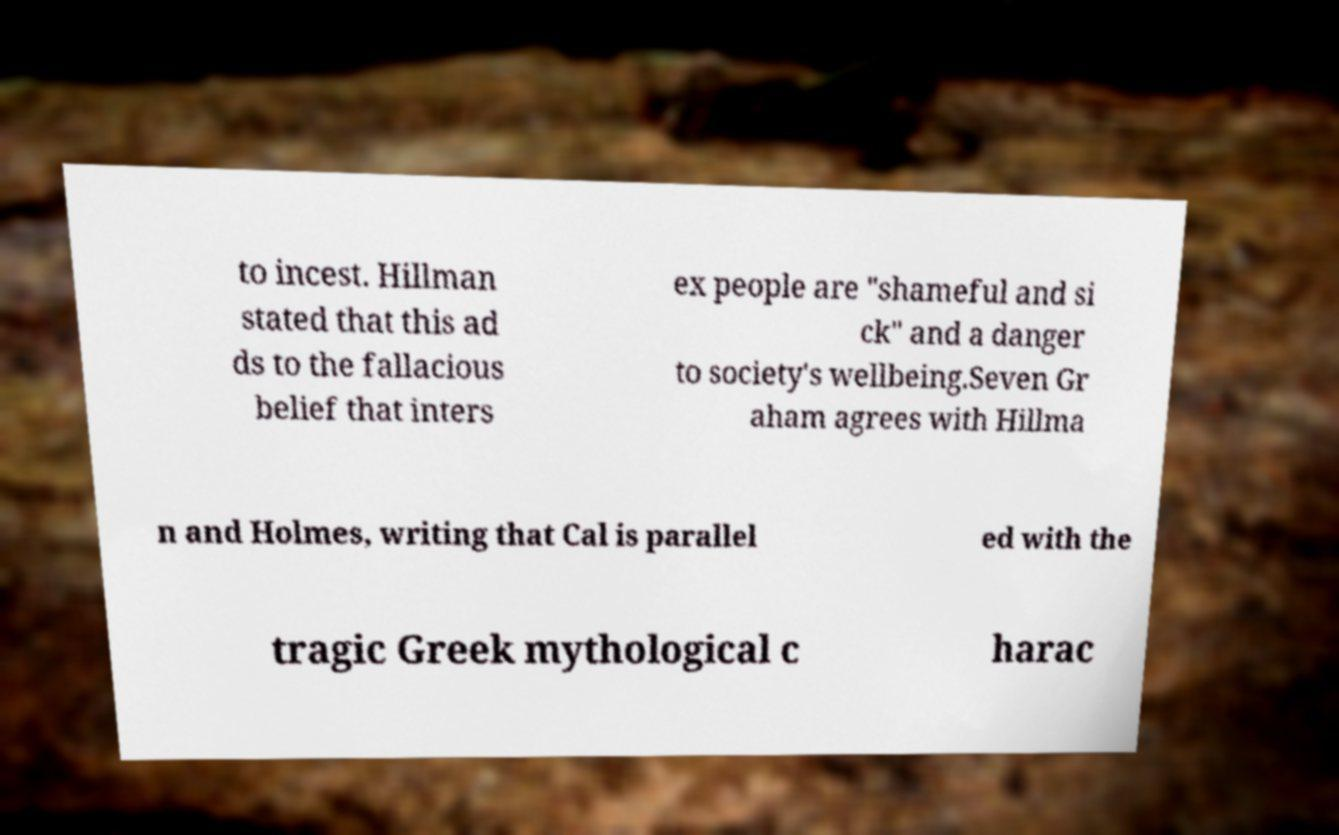For documentation purposes, I need the text within this image transcribed. Could you provide that? to incest. Hillman stated that this ad ds to the fallacious belief that inters ex people are "shameful and si ck" and a danger to society's wellbeing.Seven Gr aham agrees with Hillma n and Holmes, writing that Cal is parallel ed with the tragic Greek mythological c harac 